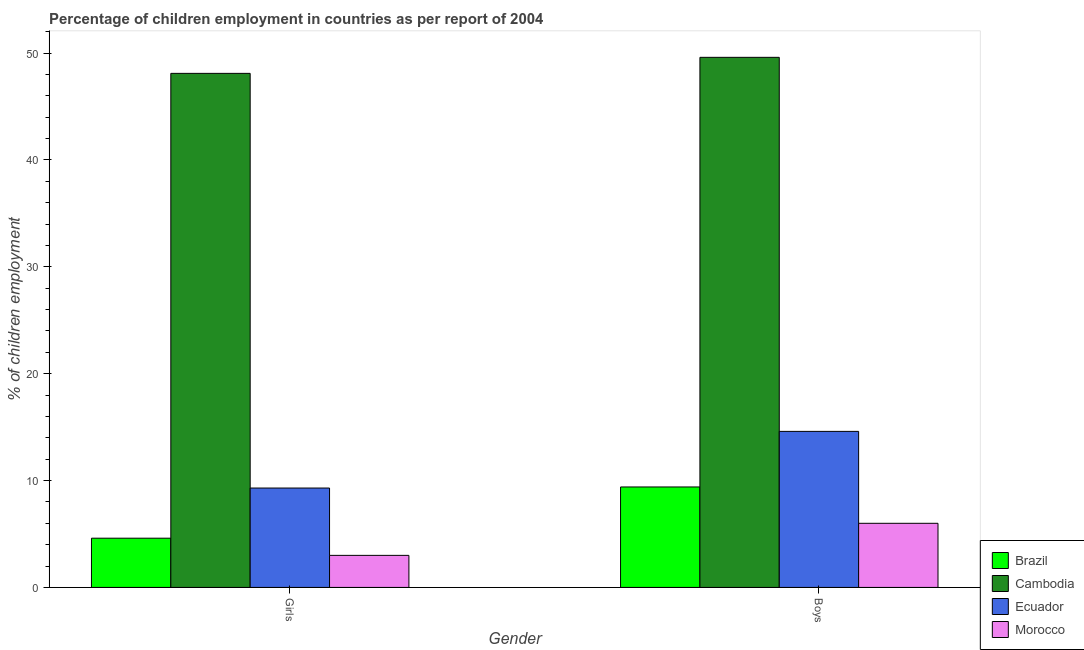How many different coloured bars are there?
Your answer should be compact. 4. How many groups of bars are there?
Your answer should be very brief. 2. How many bars are there on the 1st tick from the left?
Provide a short and direct response. 4. How many bars are there on the 1st tick from the right?
Provide a succinct answer. 4. What is the label of the 1st group of bars from the left?
Your answer should be compact. Girls. What is the percentage of employed boys in Ecuador?
Make the answer very short. 14.6. Across all countries, what is the maximum percentage of employed boys?
Your answer should be compact. 49.6. Across all countries, what is the minimum percentage of employed girls?
Provide a succinct answer. 3. In which country was the percentage of employed boys maximum?
Provide a short and direct response. Cambodia. In which country was the percentage of employed girls minimum?
Keep it short and to the point. Morocco. What is the total percentage of employed boys in the graph?
Your answer should be compact. 79.6. What is the difference between the percentage of employed girls in Ecuador and that in Morocco?
Give a very brief answer. 6.3. What is the average percentage of employed boys per country?
Your answer should be compact. 19.9. What is the ratio of the percentage of employed boys in Ecuador to that in Cambodia?
Make the answer very short. 0.29. In how many countries, is the percentage of employed girls greater than the average percentage of employed girls taken over all countries?
Give a very brief answer. 1. What does the 2nd bar from the left in Girls represents?
Keep it short and to the point. Cambodia. What does the 2nd bar from the right in Boys represents?
Offer a terse response. Ecuador. How many bars are there?
Make the answer very short. 8. Are all the bars in the graph horizontal?
Ensure brevity in your answer.  No. How many countries are there in the graph?
Provide a short and direct response. 4. What is the difference between two consecutive major ticks on the Y-axis?
Ensure brevity in your answer.  10. Where does the legend appear in the graph?
Keep it short and to the point. Bottom right. How are the legend labels stacked?
Make the answer very short. Vertical. What is the title of the graph?
Give a very brief answer. Percentage of children employment in countries as per report of 2004. What is the label or title of the X-axis?
Provide a succinct answer. Gender. What is the label or title of the Y-axis?
Give a very brief answer. % of children employment. What is the % of children employment in Brazil in Girls?
Offer a very short reply. 4.61. What is the % of children employment in Cambodia in Girls?
Your response must be concise. 48.1. What is the % of children employment of Morocco in Girls?
Give a very brief answer. 3. What is the % of children employment in Cambodia in Boys?
Provide a short and direct response. 49.6. What is the % of children employment in Ecuador in Boys?
Your answer should be compact. 14.6. What is the % of children employment of Morocco in Boys?
Provide a succinct answer. 6. Across all Gender, what is the maximum % of children employment in Cambodia?
Keep it short and to the point. 49.6. Across all Gender, what is the maximum % of children employment in Ecuador?
Offer a terse response. 14.6. Across all Gender, what is the minimum % of children employment in Brazil?
Give a very brief answer. 4.61. Across all Gender, what is the minimum % of children employment in Cambodia?
Your answer should be very brief. 48.1. Across all Gender, what is the minimum % of children employment in Morocco?
Ensure brevity in your answer.  3. What is the total % of children employment in Brazil in the graph?
Make the answer very short. 14.01. What is the total % of children employment in Cambodia in the graph?
Provide a short and direct response. 97.7. What is the total % of children employment in Ecuador in the graph?
Your response must be concise. 23.9. What is the difference between the % of children employment of Brazil in Girls and that in Boys?
Your answer should be compact. -4.79. What is the difference between the % of children employment of Ecuador in Girls and that in Boys?
Make the answer very short. -5.3. What is the difference between the % of children employment in Morocco in Girls and that in Boys?
Keep it short and to the point. -3. What is the difference between the % of children employment of Brazil in Girls and the % of children employment of Cambodia in Boys?
Provide a short and direct response. -44.99. What is the difference between the % of children employment in Brazil in Girls and the % of children employment in Ecuador in Boys?
Your answer should be very brief. -9.99. What is the difference between the % of children employment of Brazil in Girls and the % of children employment of Morocco in Boys?
Offer a terse response. -1.39. What is the difference between the % of children employment in Cambodia in Girls and the % of children employment in Ecuador in Boys?
Your answer should be compact. 33.5. What is the difference between the % of children employment of Cambodia in Girls and the % of children employment of Morocco in Boys?
Make the answer very short. 42.1. What is the difference between the % of children employment of Ecuador in Girls and the % of children employment of Morocco in Boys?
Make the answer very short. 3.3. What is the average % of children employment in Brazil per Gender?
Keep it short and to the point. 7. What is the average % of children employment of Cambodia per Gender?
Ensure brevity in your answer.  48.85. What is the average % of children employment of Ecuador per Gender?
Ensure brevity in your answer.  11.95. What is the average % of children employment in Morocco per Gender?
Your answer should be very brief. 4.5. What is the difference between the % of children employment of Brazil and % of children employment of Cambodia in Girls?
Provide a succinct answer. -43.49. What is the difference between the % of children employment in Brazil and % of children employment in Ecuador in Girls?
Keep it short and to the point. -4.69. What is the difference between the % of children employment in Brazil and % of children employment in Morocco in Girls?
Your response must be concise. 1.61. What is the difference between the % of children employment in Cambodia and % of children employment in Ecuador in Girls?
Make the answer very short. 38.8. What is the difference between the % of children employment in Cambodia and % of children employment in Morocco in Girls?
Your response must be concise. 45.1. What is the difference between the % of children employment of Ecuador and % of children employment of Morocco in Girls?
Provide a succinct answer. 6.3. What is the difference between the % of children employment of Brazil and % of children employment of Cambodia in Boys?
Ensure brevity in your answer.  -40.2. What is the difference between the % of children employment in Brazil and % of children employment in Morocco in Boys?
Offer a terse response. 3.4. What is the difference between the % of children employment in Cambodia and % of children employment in Ecuador in Boys?
Your answer should be compact. 35. What is the difference between the % of children employment of Cambodia and % of children employment of Morocco in Boys?
Give a very brief answer. 43.6. What is the ratio of the % of children employment of Brazil in Girls to that in Boys?
Your response must be concise. 0.49. What is the ratio of the % of children employment in Cambodia in Girls to that in Boys?
Give a very brief answer. 0.97. What is the ratio of the % of children employment in Ecuador in Girls to that in Boys?
Your response must be concise. 0.64. What is the difference between the highest and the second highest % of children employment in Brazil?
Offer a very short reply. 4.79. What is the difference between the highest and the second highest % of children employment in Cambodia?
Offer a very short reply. 1.5. What is the difference between the highest and the second highest % of children employment of Morocco?
Give a very brief answer. 3. What is the difference between the highest and the lowest % of children employment in Brazil?
Offer a terse response. 4.79. 